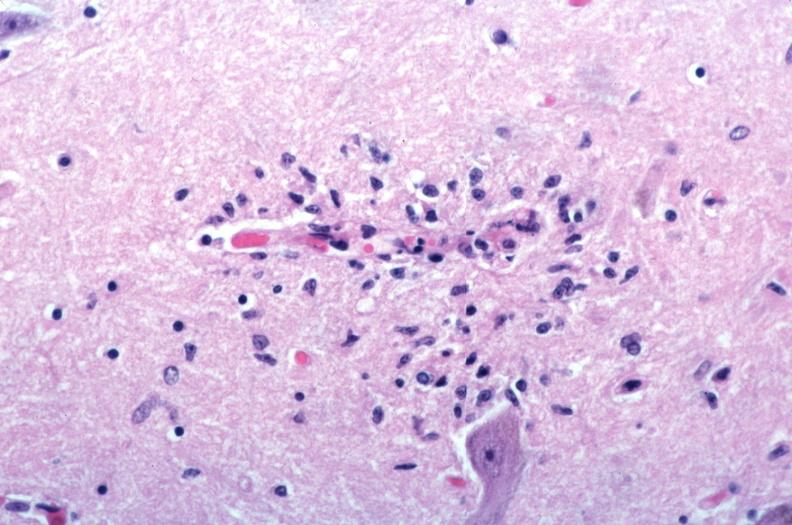s nervous present?
Answer the question using a single word or phrase. Yes 